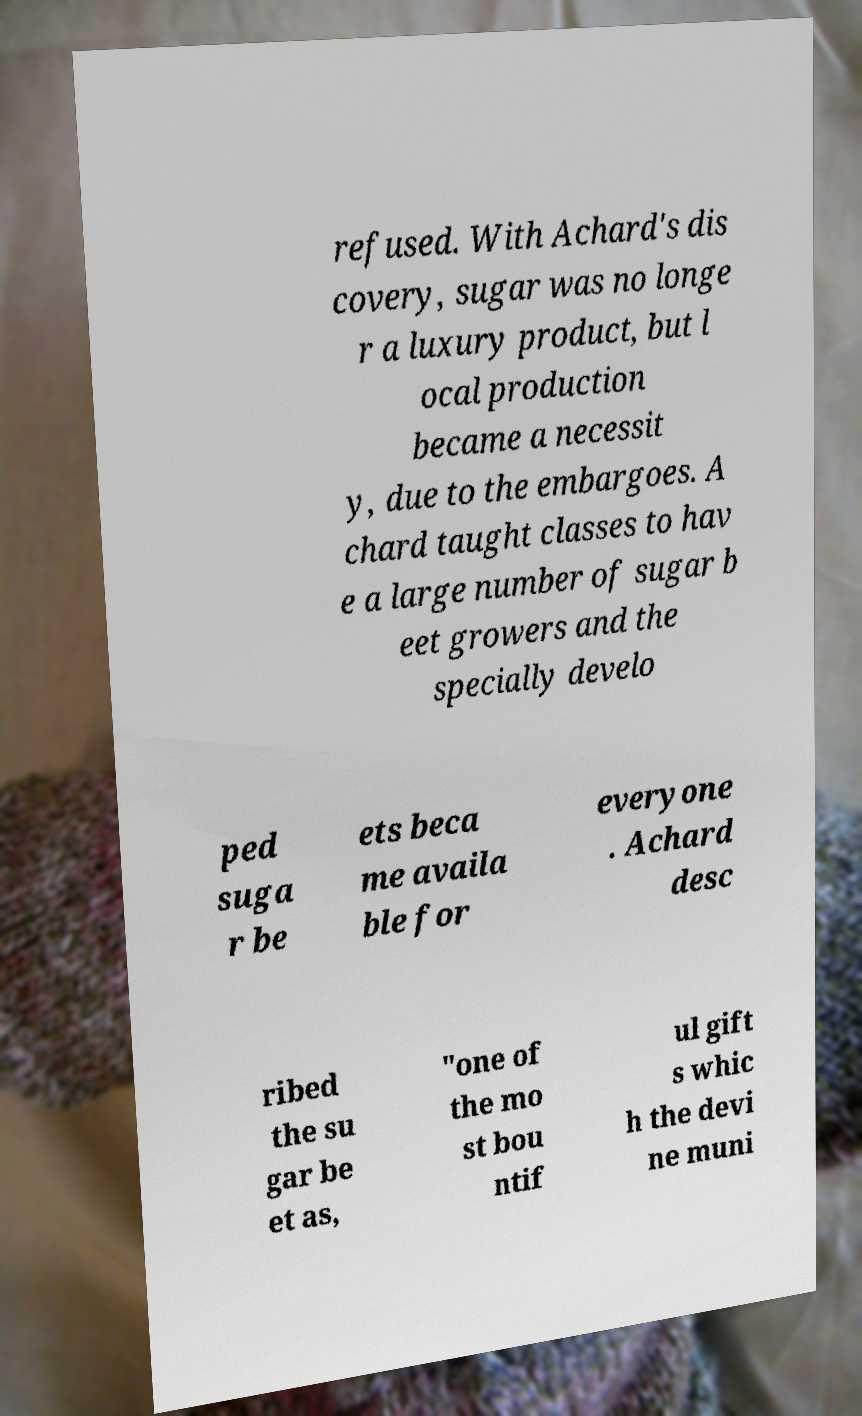There's text embedded in this image that I need extracted. Can you transcribe it verbatim? refused. With Achard's dis covery, sugar was no longe r a luxury product, but l ocal production became a necessit y, due to the embargoes. A chard taught classes to hav e a large number of sugar b eet growers and the specially develo ped suga r be ets beca me availa ble for everyone . Achard desc ribed the su gar be et as, "one of the mo st bou ntif ul gift s whic h the devi ne muni 